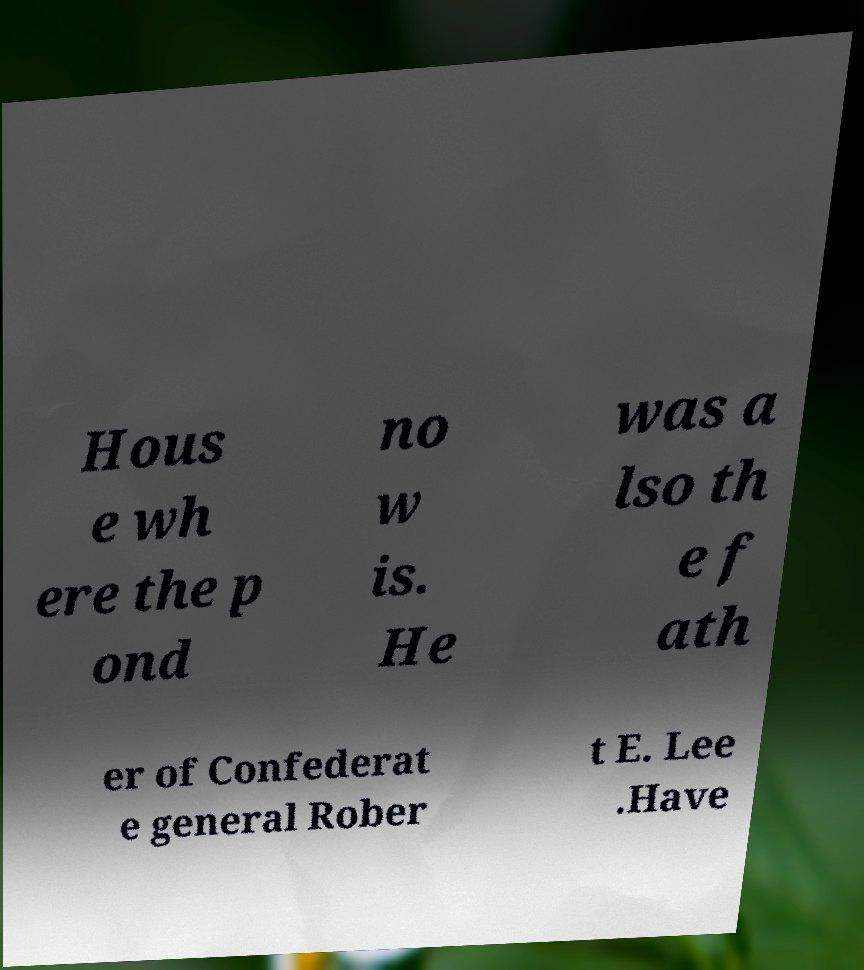Please identify and transcribe the text found in this image. Hous e wh ere the p ond no w is. He was a lso th e f ath er of Confederat e general Rober t E. Lee .Have 